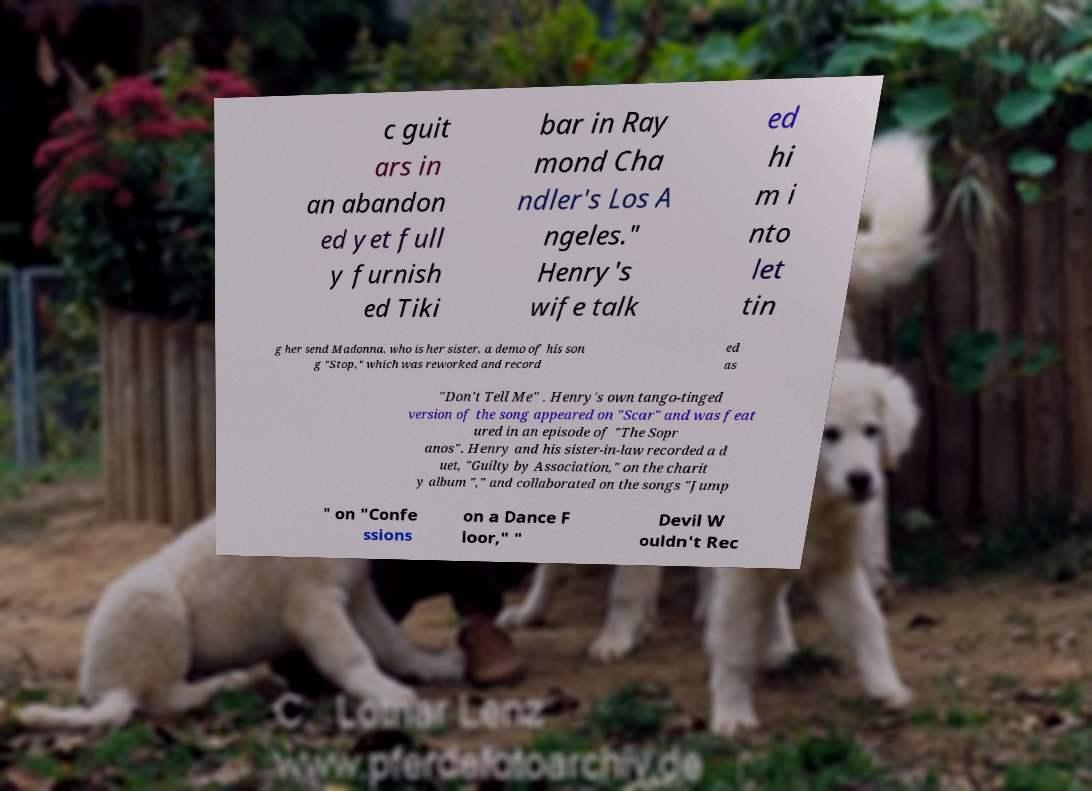What messages or text are displayed in this image? I need them in a readable, typed format. c guit ars in an abandon ed yet full y furnish ed Tiki bar in Ray mond Cha ndler's Los A ngeles." Henry's wife talk ed hi m i nto let tin g her send Madonna, who is her sister, a demo of his son g "Stop," which was reworked and record ed as "Don't Tell Me" . Henry's own tango-tinged version of the song appeared on "Scar" and was feat ured in an episode of "The Sopr anos". Henry and his sister-in-law recorded a d uet, "Guilty by Association," on the charit y album "," and collaborated on the songs "Jump " on "Confe ssions on a Dance F loor," " Devil W ouldn't Rec 